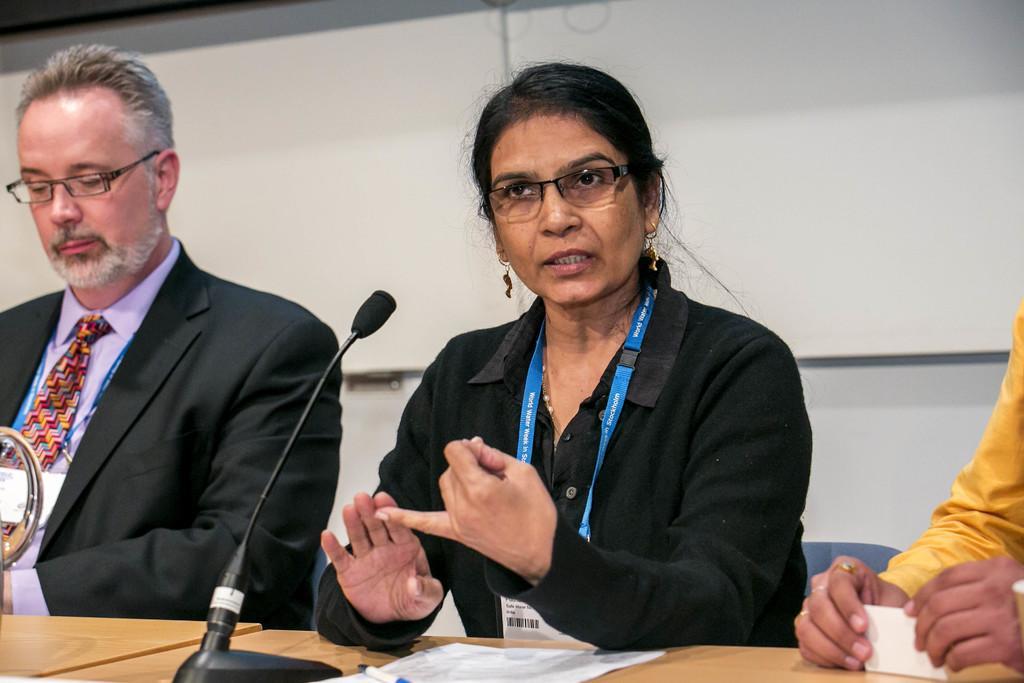In one or two sentences, can you explain what this image depicts? In this picture we can see three persons. In the middle of the picture we can see a woman talking on the mike and she wore spectacles. There is a table. On the table there are papers, pen, and a mike. In the background there is a wall. 